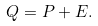Convert formula to latex. <formula><loc_0><loc_0><loc_500><loc_500>Q = P + E .</formula> 